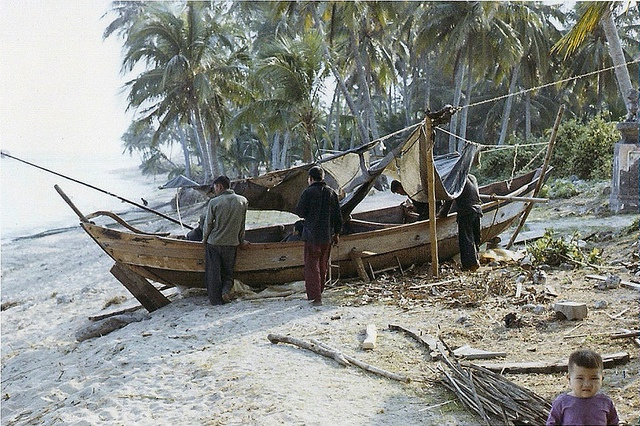Describe the objects in this image and their specific colors. I can see boat in white, black, and gray tones, people in white, black, gray, and darkgray tones, people in white, black, gray, and darkgray tones, people in white, gray, purple, black, and darkgray tones, and people in white, black, gray, darkgray, and lightgray tones in this image. 